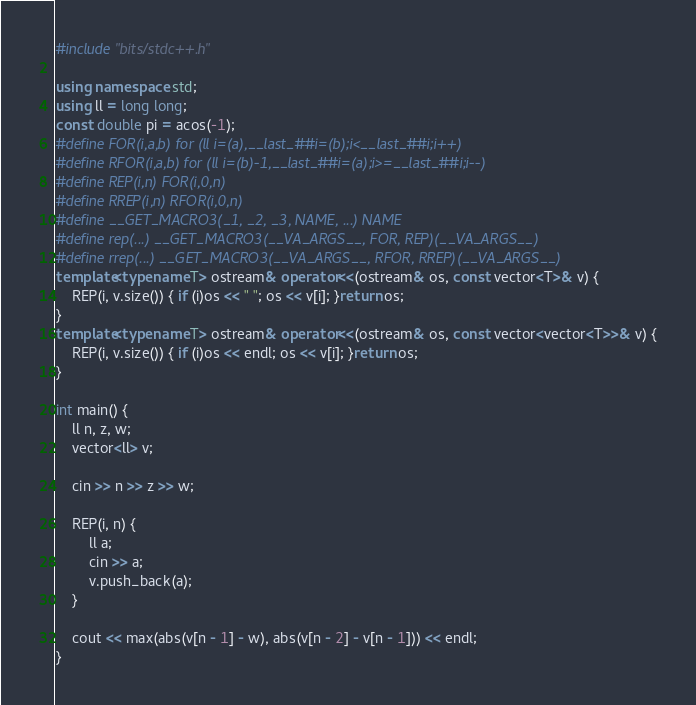<code> <loc_0><loc_0><loc_500><loc_500><_C++_>
#include "bits/stdc++.h"

using namespace std;
using ll = long long;
const double pi = acos(-1);
#define FOR(i,a,b) for (ll i=(a),__last_##i=(b);i<__last_##i;i++)
#define RFOR(i,a,b) for (ll i=(b)-1,__last_##i=(a);i>=__last_##i;i--)
#define REP(i,n) FOR(i,0,n)
#define RREP(i,n) RFOR(i,0,n)
#define __GET_MACRO3(_1, _2, _3, NAME, ...) NAME
#define rep(...) __GET_MACRO3(__VA_ARGS__, FOR, REP)(__VA_ARGS__)
#define rrep(...) __GET_MACRO3(__VA_ARGS__, RFOR, RREP)(__VA_ARGS__)
template<typename T> ostream& operator<<(ostream& os, const vector<T>& v) {
	REP(i, v.size()) { if (i)os << " "; os << v[i]; }return os;
}
template<typename T> ostream& operator<<(ostream& os, const vector<vector<T>>& v) {
	REP(i, v.size()) { if (i)os << endl; os << v[i]; }return os;
}

int main() {
	ll n, z, w;
	vector<ll> v;

	cin >> n >> z >> w;

	REP(i, n) {
		ll a;
		cin >> a;
		v.push_back(a);
	}

	cout << max(abs(v[n - 1] - w), abs(v[n - 2] - v[n - 1])) << endl;
}</code> 